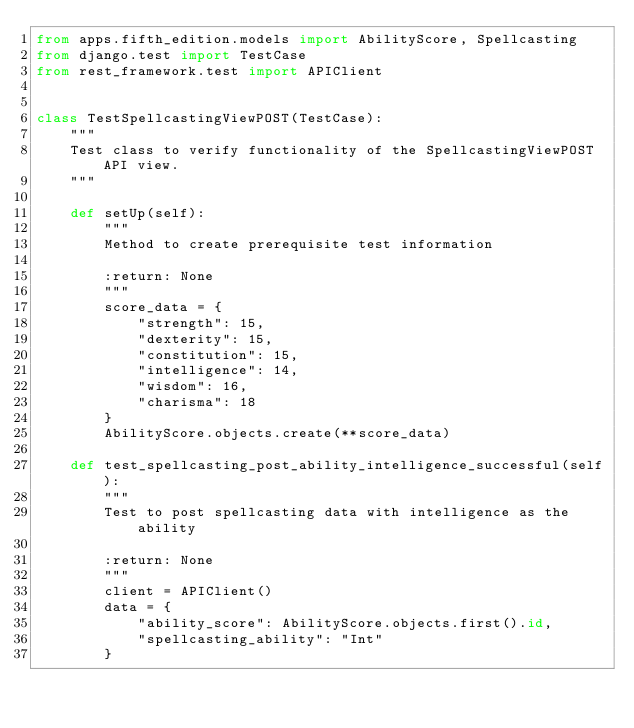Convert code to text. <code><loc_0><loc_0><loc_500><loc_500><_Python_>from apps.fifth_edition.models import AbilityScore, Spellcasting
from django.test import TestCase
from rest_framework.test import APIClient


class TestSpellcastingViewPOST(TestCase):
    """
    Test class to verify functionality of the SpellcastingViewPOST API view.
    """

    def setUp(self):
        """
        Method to create prerequisite test information

        :return: None
        """
        score_data = {
            "strength": 15,
            "dexterity": 15,
            "constitution": 15,
            "intelligence": 14,
            "wisdom": 16,
            "charisma": 18
        }
        AbilityScore.objects.create(**score_data)

    def test_spellcasting_post_ability_intelligence_successful(self):
        """
        Test to post spellcasting data with intelligence as the ability

        :return: None
        """
        client = APIClient()
        data = {
            "ability_score": AbilityScore.objects.first().id,
            "spellcasting_ability": "Int"
        }
</code> 